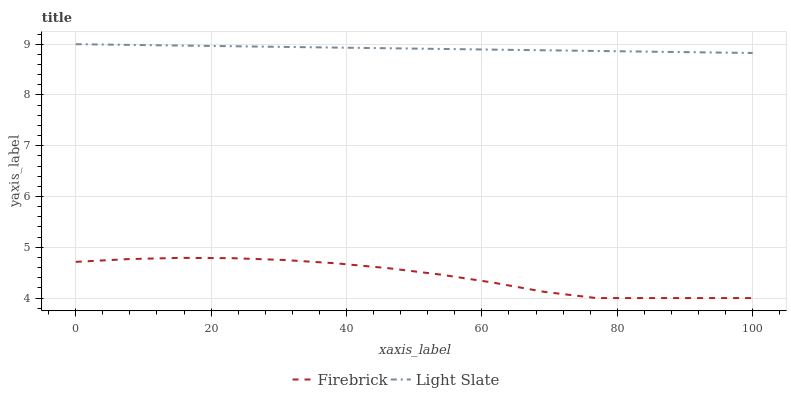Does Firebrick have the minimum area under the curve?
Answer yes or no. Yes. Does Light Slate have the maximum area under the curve?
Answer yes or no. Yes. Does Firebrick have the maximum area under the curve?
Answer yes or no. No. Is Light Slate the smoothest?
Answer yes or no. Yes. Is Firebrick the roughest?
Answer yes or no. Yes. Is Firebrick the smoothest?
Answer yes or no. No. Does Firebrick have the lowest value?
Answer yes or no. Yes. Does Light Slate have the highest value?
Answer yes or no. Yes. Does Firebrick have the highest value?
Answer yes or no. No. Is Firebrick less than Light Slate?
Answer yes or no. Yes. Is Light Slate greater than Firebrick?
Answer yes or no. Yes. Does Firebrick intersect Light Slate?
Answer yes or no. No. 